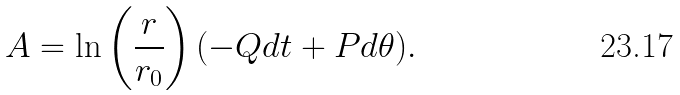<formula> <loc_0><loc_0><loc_500><loc_500>A = \ln \left ( \frac { r } { r _ { 0 } } \right ) ( - Q d t + P d \theta ) .</formula> 